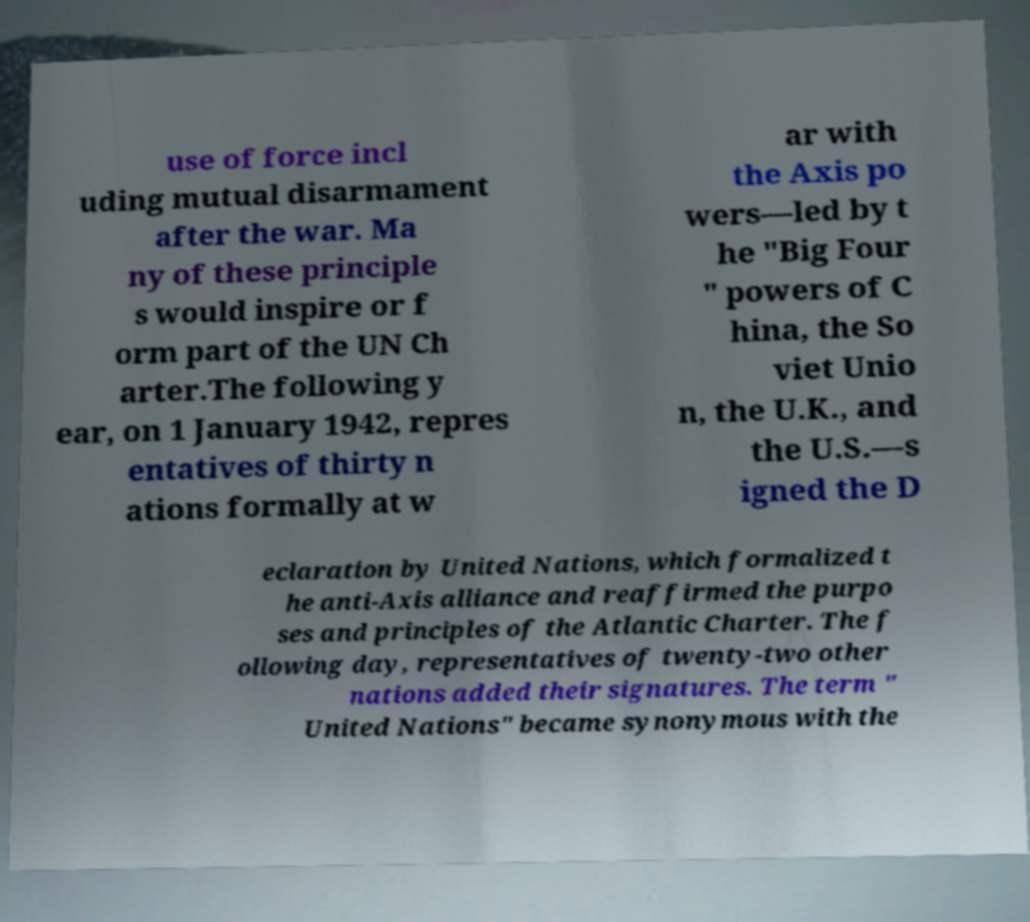There's text embedded in this image that I need extracted. Can you transcribe it verbatim? use of force incl uding mutual disarmament after the war. Ma ny of these principle s would inspire or f orm part of the UN Ch arter.The following y ear, on 1 January 1942, repres entatives of thirty n ations formally at w ar with the Axis po wers—led by t he "Big Four " powers of C hina, the So viet Unio n, the U.K., and the U.S.—s igned the D eclaration by United Nations, which formalized t he anti-Axis alliance and reaffirmed the purpo ses and principles of the Atlantic Charter. The f ollowing day, representatives of twenty-two other nations added their signatures. The term " United Nations" became synonymous with the 